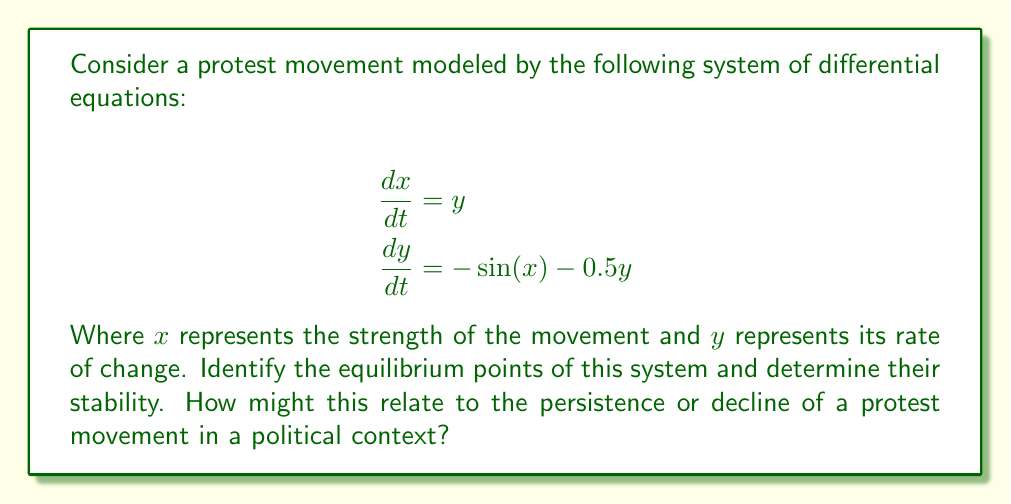Can you solve this math problem? To solve this problem, we'll follow these steps:

1) Find the equilibrium points:
   Set $\frac{dx}{dt} = 0$ and $\frac{dy}{dt} = 0$:
   
   $$\begin{align}
   0 &= y \\
   0 &= -\sin(x) - 0.5y
   \end{align}$$

   From the first equation, $y = 0$. Substituting this into the second equation:
   
   $0 = -\sin(x)$

   This is satisfied when $x = n\pi$, where $n$ is any integer.

   Therefore, the equilibrium points are $(n\pi, 0)$ for all integers $n$.

2) Determine stability:
   To determine stability, we need to evaluate the Jacobian matrix at each equilibrium point:

   $$J = \begin{bmatrix}
   \frac{\partial}{\partial x}(\frac{dx}{dt}) & \frac{\partial}{\partial y}(\frac{dx}{dt}) \\
   \frac{\partial}{\partial x}(\frac{dy}{dt}) & \frac{\partial}{\partial y}(\frac{dy}{dt})
   \end{bmatrix} = \begin{bmatrix}
   0 & 1 \\
   -\cos(x) & -0.5
   \end{bmatrix}$$

   At equilibrium points where $x = 2n\pi$:
   $$J = \begin{bmatrix}
   0 & 1 \\
   -1 & -0.5
   \end{bmatrix}$$

   The eigenvalues are $\lambda = -0.25 \pm i\sqrt{0.9375}$

   Since the real parts are negative, these are stable spiral points.

   At equilibrium points where $x = (2n+1)\pi$:
   $$J = \begin{bmatrix}
   0 & 1 \\
   1 & -0.5
   \end{bmatrix}$$

   The eigenvalues are $\lambda = 0.25 \pm \sqrt{1.0625}$

   Since one eigenvalue is positive, these are unstable saddle points.

3) Political interpretation:
   Stable spiral points (at $x = 2n\pi$) represent states where the protest movement naturally returns to equilibrium, possibly indicating societal stability or effective suppression of protests.
   
   Unstable saddle points (at $x = (2n+1)\pi$) represent states where the movement can either grow or decay rapidly, possibly indicating potential for sudden social changes or revolutions.

   The periodic nature of the equilibrium points suggests that protest movements may go through cycles of growth and decline over time.
Answer: Equilibrium points: $(n\pi, 0)$ for integer $n$. Stable spirals at $x = 2n\pi$, unstable saddles at $x = (2n+1)\pi$. 